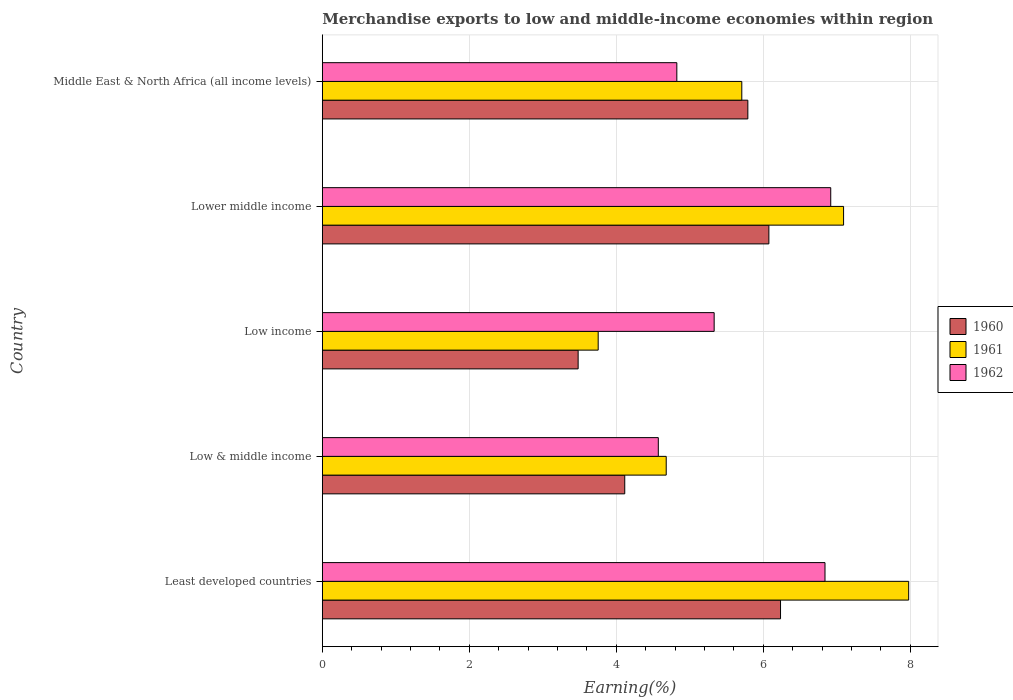How many groups of bars are there?
Provide a succinct answer. 5. Are the number of bars per tick equal to the number of legend labels?
Offer a terse response. Yes. Are the number of bars on each tick of the Y-axis equal?
Ensure brevity in your answer.  Yes. How many bars are there on the 3rd tick from the top?
Offer a very short reply. 3. What is the label of the 1st group of bars from the top?
Offer a very short reply. Middle East & North Africa (all income levels). In how many cases, is the number of bars for a given country not equal to the number of legend labels?
Offer a very short reply. 0. What is the percentage of amount earned from merchandise exports in 1961 in Least developed countries?
Provide a succinct answer. 7.98. Across all countries, what is the maximum percentage of amount earned from merchandise exports in 1961?
Your answer should be very brief. 7.98. Across all countries, what is the minimum percentage of amount earned from merchandise exports in 1962?
Provide a short and direct response. 4.57. In which country was the percentage of amount earned from merchandise exports in 1962 maximum?
Your answer should be compact. Lower middle income. In which country was the percentage of amount earned from merchandise exports in 1961 minimum?
Offer a terse response. Low income. What is the total percentage of amount earned from merchandise exports in 1961 in the graph?
Offer a terse response. 29.21. What is the difference between the percentage of amount earned from merchandise exports in 1961 in Low & middle income and that in Low income?
Provide a short and direct response. 0.93. What is the difference between the percentage of amount earned from merchandise exports in 1960 in Lower middle income and the percentage of amount earned from merchandise exports in 1961 in Low & middle income?
Your answer should be compact. 1.4. What is the average percentage of amount earned from merchandise exports in 1960 per country?
Your answer should be very brief. 5.14. What is the difference between the percentage of amount earned from merchandise exports in 1962 and percentage of amount earned from merchandise exports in 1961 in Least developed countries?
Provide a short and direct response. -1.14. What is the ratio of the percentage of amount earned from merchandise exports in 1961 in Low & middle income to that in Low income?
Your response must be concise. 1.25. Is the difference between the percentage of amount earned from merchandise exports in 1962 in Low & middle income and Lower middle income greater than the difference between the percentage of amount earned from merchandise exports in 1961 in Low & middle income and Lower middle income?
Offer a very short reply. Yes. What is the difference between the highest and the second highest percentage of amount earned from merchandise exports in 1961?
Your response must be concise. 0.89. What is the difference between the highest and the lowest percentage of amount earned from merchandise exports in 1962?
Your answer should be very brief. 2.35. In how many countries, is the percentage of amount earned from merchandise exports in 1962 greater than the average percentage of amount earned from merchandise exports in 1962 taken over all countries?
Ensure brevity in your answer.  2. How many bars are there?
Ensure brevity in your answer.  15. How many countries are there in the graph?
Your answer should be very brief. 5. Are the values on the major ticks of X-axis written in scientific E-notation?
Your answer should be very brief. No. Does the graph contain grids?
Make the answer very short. Yes. Where does the legend appear in the graph?
Make the answer very short. Center right. How are the legend labels stacked?
Make the answer very short. Vertical. What is the title of the graph?
Give a very brief answer. Merchandise exports to low and middle-income economies within region. What is the label or title of the X-axis?
Your response must be concise. Earning(%). What is the label or title of the Y-axis?
Provide a succinct answer. Country. What is the Earning(%) of 1960 in Least developed countries?
Offer a terse response. 6.23. What is the Earning(%) of 1961 in Least developed countries?
Offer a terse response. 7.98. What is the Earning(%) of 1962 in Least developed countries?
Offer a terse response. 6.84. What is the Earning(%) of 1960 in Low & middle income?
Your response must be concise. 4.11. What is the Earning(%) in 1961 in Low & middle income?
Provide a succinct answer. 4.68. What is the Earning(%) in 1962 in Low & middle income?
Provide a succinct answer. 4.57. What is the Earning(%) of 1960 in Low income?
Provide a succinct answer. 3.48. What is the Earning(%) of 1961 in Low income?
Your response must be concise. 3.75. What is the Earning(%) in 1962 in Low income?
Your response must be concise. 5.33. What is the Earning(%) of 1960 in Lower middle income?
Give a very brief answer. 6.07. What is the Earning(%) in 1961 in Lower middle income?
Your answer should be compact. 7.09. What is the Earning(%) of 1962 in Lower middle income?
Provide a succinct answer. 6.92. What is the Earning(%) in 1960 in Middle East & North Africa (all income levels)?
Your answer should be very brief. 5.79. What is the Earning(%) in 1961 in Middle East & North Africa (all income levels)?
Your response must be concise. 5.71. What is the Earning(%) of 1962 in Middle East & North Africa (all income levels)?
Keep it short and to the point. 4.82. Across all countries, what is the maximum Earning(%) of 1960?
Your answer should be very brief. 6.23. Across all countries, what is the maximum Earning(%) of 1961?
Ensure brevity in your answer.  7.98. Across all countries, what is the maximum Earning(%) in 1962?
Offer a terse response. 6.92. Across all countries, what is the minimum Earning(%) in 1960?
Your answer should be very brief. 3.48. Across all countries, what is the minimum Earning(%) of 1961?
Keep it short and to the point. 3.75. Across all countries, what is the minimum Earning(%) in 1962?
Keep it short and to the point. 4.57. What is the total Earning(%) in 1960 in the graph?
Provide a short and direct response. 25.69. What is the total Earning(%) of 1961 in the graph?
Offer a terse response. 29.21. What is the total Earning(%) of 1962 in the graph?
Provide a succinct answer. 28.48. What is the difference between the Earning(%) of 1960 in Least developed countries and that in Low & middle income?
Offer a very short reply. 2.12. What is the difference between the Earning(%) in 1961 in Least developed countries and that in Low & middle income?
Make the answer very short. 3.3. What is the difference between the Earning(%) in 1962 in Least developed countries and that in Low & middle income?
Ensure brevity in your answer.  2.27. What is the difference between the Earning(%) in 1960 in Least developed countries and that in Low income?
Your answer should be very brief. 2.75. What is the difference between the Earning(%) of 1961 in Least developed countries and that in Low income?
Offer a very short reply. 4.22. What is the difference between the Earning(%) in 1962 in Least developed countries and that in Low income?
Offer a terse response. 1.51. What is the difference between the Earning(%) of 1960 in Least developed countries and that in Lower middle income?
Offer a terse response. 0.16. What is the difference between the Earning(%) in 1961 in Least developed countries and that in Lower middle income?
Your answer should be compact. 0.89. What is the difference between the Earning(%) of 1962 in Least developed countries and that in Lower middle income?
Provide a short and direct response. -0.08. What is the difference between the Earning(%) in 1960 in Least developed countries and that in Middle East & North Africa (all income levels)?
Offer a very short reply. 0.44. What is the difference between the Earning(%) of 1961 in Least developed countries and that in Middle East & North Africa (all income levels)?
Keep it short and to the point. 2.27. What is the difference between the Earning(%) in 1962 in Least developed countries and that in Middle East & North Africa (all income levels)?
Offer a very short reply. 2.02. What is the difference between the Earning(%) of 1960 in Low & middle income and that in Low income?
Keep it short and to the point. 0.63. What is the difference between the Earning(%) of 1961 in Low & middle income and that in Low income?
Your answer should be very brief. 0.93. What is the difference between the Earning(%) in 1962 in Low & middle income and that in Low income?
Offer a terse response. -0.76. What is the difference between the Earning(%) in 1960 in Low & middle income and that in Lower middle income?
Keep it short and to the point. -1.96. What is the difference between the Earning(%) in 1961 in Low & middle income and that in Lower middle income?
Make the answer very short. -2.41. What is the difference between the Earning(%) in 1962 in Low & middle income and that in Lower middle income?
Keep it short and to the point. -2.35. What is the difference between the Earning(%) in 1960 in Low & middle income and that in Middle East & North Africa (all income levels)?
Your answer should be very brief. -1.67. What is the difference between the Earning(%) of 1961 in Low & middle income and that in Middle East & North Africa (all income levels)?
Make the answer very short. -1.03. What is the difference between the Earning(%) in 1962 in Low & middle income and that in Middle East & North Africa (all income levels)?
Your answer should be compact. -0.25. What is the difference between the Earning(%) in 1960 in Low income and that in Lower middle income?
Provide a succinct answer. -2.59. What is the difference between the Earning(%) of 1961 in Low income and that in Lower middle income?
Your answer should be compact. -3.34. What is the difference between the Earning(%) in 1962 in Low income and that in Lower middle income?
Keep it short and to the point. -1.59. What is the difference between the Earning(%) of 1960 in Low income and that in Middle East & North Africa (all income levels)?
Your answer should be very brief. -2.31. What is the difference between the Earning(%) of 1961 in Low income and that in Middle East & North Africa (all income levels)?
Keep it short and to the point. -1.95. What is the difference between the Earning(%) in 1962 in Low income and that in Middle East & North Africa (all income levels)?
Offer a very short reply. 0.51. What is the difference between the Earning(%) of 1960 in Lower middle income and that in Middle East & North Africa (all income levels)?
Make the answer very short. 0.29. What is the difference between the Earning(%) in 1961 in Lower middle income and that in Middle East & North Africa (all income levels)?
Provide a succinct answer. 1.38. What is the difference between the Earning(%) in 1962 in Lower middle income and that in Middle East & North Africa (all income levels)?
Make the answer very short. 2.09. What is the difference between the Earning(%) of 1960 in Least developed countries and the Earning(%) of 1961 in Low & middle income?
Offer a very short reply. 1.56. What is the difference between the Earning(%) of 1960 in Least developed countries and the Earning(%) of 1962 in Low & middle income?
Offer a very short reply. 1.66. What is the difference between the Earning(%) in 1961 in Least developed countries and the Earning(%) in 1962 in Low & middle income?
Provide a succinct answer. 3.41. What is the difference between the Earning(%) of 1960 in Least developed countries and the Earning(%) of 1961 in Low income?
Offer a very short reply. 2.48. What is the difference between the Earning(%) of 1960 in Least developed countries and the Earning(%) of 1962 in Low income?
Ensure brevity in your answer.  0.9. What is the difference between the Earning(%) of 1961 in Least developed countries and the Earning(%) of 1962 in Low income?
Your answer should be compact. 2.65. What is the difference between the Earning(%) of 1960 in Least developed countries and the Earning(%) of 1961 in Lower middle income?
Offer a terse response. -0.86. What is the difference between the Earning(%) in 1960 in Least developed countries and the Earning(%) in 1962 in Lower middle income?
Make the answer very short. -0.68. What is the difference between the Earning(%) in 1961 in Least developed countries and the Earning(%) in 1962 in Lower middle income?
Your answer should be very brief. 1.06. What is the difference between the Earning(%) in 1960 in Least developed countries and the Earning(%) in 1961 in Middle East & North Africa (all income levels)?
Provide a short and direct response. 0.53. What is the difference between the Earning(%) in 1960 in Least developed countries and the Earning(%) in 1962 in Middle East & North Africa (all income levels)?
Provide a succinct answer. 1.41. What is the difference between the Earning(%) in 1961 in Least developed countries and the Earning(%) in 1962 in Middle East & North Africa (all income levels)?
Offer a very short reply. 3.15. What is the difference between the Earning(%) of 1960 in Low & middle income and the Earning(%) of 1961 in Low income?
Ensure brevity in your answer.  0.36. What is the difference between the Earning(%) in 1960 in Low & middle income and the Earning(%) in 1962 in Low income?
Provide a short and direct response. -1.22. What is the difference between the Earning(%) in 1961 in Low & middle income and the Earning(%) in 1962 in Low income?
Provide a short and direct response. -0.65. What is the difference between the Earning(%) of 1960 in Low & middle income and the Earning(%) of 1961 in Lower middle income?
Offer a terse response. -2.98. What is the difference between the Earning(%) of 1960 in Low & middle income and the Earning(%) of 1962 in Lower middle income?
Offer a very short reply. -2.8. What is the difference between the Earning(%) in 1961 in Low & middle income and the Earning(%) in 1962 in Lower middle income?
Provide a succinct answer. -2.24. What is the difference between the Earning(%) of 1960 in Low & middle income and the Earning(%) of 1961 in Middle East & North Africa (all income levels)?
Give a very brief answer. -1.59. What is the difference between the Earning(%) of 1960 in Low & middle income and the Earning(%) of 1962 in Middle East & North Africa (all income levels)?
Offer a terse response. -0.71. What is the difference between the Earning(%) in 1961 in Low & middle income and the Earning(%) in 1962 in Middle East & North Africa (all income levels)?
Keep it short and to the point. -0.14. What is the difference between the Earning(%) of 1960 in Low income and the Earning(%) of 1961 in Lower middle income?
Keep it short and to the point. -3.61. What is the difference between the Earning(%) in 1960 in Low income and the Earning(%) in 1962 in Lower middle income?
Provide a succinct answer. -3.44. What is the difference between the Earning(%) in 1961 in Low income and the Earning(%) in 1962 in Lower middle income?
Ensure brevity in your answer.  -3.16. What is the difference between the Earning(%) of 1960 in Low income and the Earning(%) of 1961 in Middle East & North Africa (all income levels)?
Your answer should be very brief. -2.23. What is the difference between the Earning(%) of 1960 in Low income and the Earning(%) of 1962 in Middle East & North Africa (all income levels)?
Your response must be concise. -1.34. What is the difference between the Earning(%) in 1961 in Low income and the Earning(%) in 1962 in Middle East & North Africa (all income levels)?
Ensure brevity in your answer.  -1.07. What is the difference between the Earning(%) in 1960 in Lower middle income and the Earning(%) in 1961 in Middle East & North Africa (all income levels)?
Ensure brevity in your answer.  0.37. What is the difference between the Earning(%) of 1960 in Lower middle income and the Earning(%) of 1962 in Middle East & North Africa (all income levels)?
Offer a terse response. 1.25. What is the difference between the Earning(%) of 1961 in Lower middle income and the Earning(%) of 1962 in Middle East & North Africa (all income levels)?
Offer a terse response. 2.27. What is the average Earning(%) of 1960 per country?
Keep it short and to the point. 5.14. What is the average Earning(%) in 1961 per country?
Ensure brevity in your answer.  5.84. What is the average Earning(%) of 1962 per country?
Ensure brevity in your answer.  5.7. What is the difference between the Earning(%) in 1960 and Earning(%) in 1961 in Least developed countries?
Offer a very short reply. -1.74. What is the difference between the Earning(%) of 1960 and Earning(%) of 1962 in Least developed countries?
Give a very brief answer. -0.6. What is the difference between the Earning(%) of 1961 and Earning(%) of 1962 in Least developed countries?
Offer a terse response. 1.14. What is the difference between the Earning(%) in 1960 and Earning(%) in 1961 in Low & middle income?
Your answer should be very brief. -0.56. What is the difference between the Earning(%) of 1960 and Earning(%) of 1962 in Low & middle income?
Provide a short and direct response. -0.46. What is the difference between the Earning(%) in 1961 and Earning(%) in 1962 in Low & middle income?
Keep it short and to the point. 0.11. What is the difference between the Earning(%) in 1960 and Earning(%) in 1961 in Low income?
Your answer should be very brief. -0.27. What is the difference between the Earning(%) in 1960 and Earning(%) in 1962 in Low income?
Give a very brief answer. -1.85. What is the difference between the Earning(%) in 1961 and Earning(%) in 1962 in Low income?
Your response must be concise. -1.58. What is the difference between the Earning(%) in 1960 and Earning(%) in 1961 in Lower middle income?
Offer a very short reply. -1.02. What is the difference between the Earning(%) of 1960 and Earning(%) of 1962 in Lower middle income?
Your answer should be compact. -0.84. What is the difference between the Earning(%) in 1961 and Earning(%) in 1962 in Lower middle income?
Give a very brief answer. 0.17. What is the difference between the Earning(%) of 1960 and Earning(%) of 1961 in Middle East & North Africa (all income levels)?
Offer a very short reply. 0.08. What is the difference between the Earning(%) in 1960 and Earning(%) in 1962 in Middle East & North Africa (all income levels)?
Ensure brevity in your answer.  0.97. What is the difference between the Earning(%) of 1961 and Earning(%) of 1962 in Middle East & North Africa (all income levels)?
Offer a very short reply. 0.88. What is the ratio of the Earning(%) in 1960 in Least developed countries to that in Low & middle income?
Your answer should be very brief. 1.52. What is the ratio of the Earning(%) of 1961 in Least developed countries to that in Low & middle income?
Offer a very short reply. 1.71. What is the ratio of the Earning(%) in 1962 in Least developed countries to that in Low & middle income?
Make the answer very short. 1.5. What is the ratio of the Earning(%) of 1960 in Least developed countries to that in Low income?
Give a very brief answer. 1.79. What is the ratio of the Earning(%) of 1961 in Least developed countries to that in Low income?
Offer a very short reply. 2.13. What is the ratio of the Earning(%) in 1962 in Least developed countries to that in Low income?
Your answer should be compact. 1.28. What is the ratio of the Earning(%) of 1960 in Least developed countries to that in Lower middle income?
Provide a short and direct response. 1.03. What is the ratio of the Earning(%) in 1961 in Least developed countries to that in Lower middle income?
Keep it short and to the point. 1.12. What is the ratio of the Earning(%) in 1962 in Least developed countries to that in Lower middle income?
Give a very brief answer. 0.99. What is the ratio of the Earning(%) in 1960 in Least developed countries to that in Middle East & North Africa (all income levels)?
Offer a very short reply. 1.08. What is the ratio of the Earning(%) in 1961 in Least developed countries to that in Middle East & North Africa (all income levels)?
Keep it short and to the point. 1.4. What is the ratio of the Earning(%) in 1962 in Least developed countries to that in Middle East & North Africa (all income levels)?
Offer a terse response. 1.42. What is the ratio of the Earning(%) of 1960 in Low & middle income to that in Low income?
Your response must be concise. 1.18. What is the ratio of the Earning(%) in 1961 in Low & middle income to that in Low income?
Offer a very short reply. 1.25. What is the ratio of the Earning(%) in 1962 in Low & middle income to that in Low income?
Give a very brief answer. 0.86. What is the ratio of the Earning(%) in 1960 in Low & middle income to that in Lower middle income?
Your answer should be compact. 0.68. What is the ratio of the Earning(%) in 1961 in Low & middle income to that in Lower middle income?
Your answer should be compact. 0.66. What is the ratio of the Earning(%) in 1962 in Low & middle income to that in Lower middle income?
Offer a very short reply. 0.66. What is the ratio of the Earning(%) in 1960 in Low & middle income to that in Middle East & North Africa (all income levels)?
Offer a very short reply. 0.71. What is the ratio of the Earning(%) of 1961 in Low & middle income to that in Middle East & North Africa (all income levels)?
Provide a short and direct response. 0.82. What is the ratio of the Earning(%) in 1962 in Low & middle income to that in Middle East & North Africa (all income levels)?
Your answer should be compact. 0.95. What is the ratio of the Earning(%) of 1960 in Low income to that in Lower middle income?
Give a very brief answer. 0.57. What is the ratio of the Earning(%) of 1961 in Low income to that in Lower middle income?
Offer a terse response. 0.53. What is the ratio of the Earning(%) in 1962 in Low income to that in Lower middle income?
Your answer should be very brief. 0.77. What is the ratio of the Earning(%) in 1960 in Low income to that in Middle East & North Africa (all income levels)?
Offer a terse response. 0.6. What is the ratio of the Earning(%) of 1961 in Low income to that in Middle East & North Africa (all income levels)?
Your response must be concise. 0.66. What is the ratio of the Earning(%) of 1962 in Low income to that in Middle East & North Africa (all income levels)?
Make the answer very short. 1.11. What is the ratio of the Earning(%) in 1960 in Lower middle income to that in Middle East & North Africa (all income levels)?
Your answer should be very brief. 1.05. What is the ratio of the Earning(%) of 1961 in Lower middle income to that in Middle East & North Africa (all income levels)?
Provide a succinct answer. 1.24. What is the ratio of the Earning(%) of 1962 in Lower middle income to that in Middle East & North Africa (all income levels)?
Provide a short and direct response. 1.43. What is the difference between the highest and the second highest Earning(%) of 1960?
Keep it short and to the point. 0.16. What is the difference between the highest and the second highest Earning(%) in 1961?
Offer a very short reply. 0.89. What is the difference between the highest and the second highest Earning(%) in 1962?
Your answer should be very brief. 0.08. What is the difference between the highest and the lowest Earning(%) of 1960?
Ensure brevity in your answer.  2.75. What is the difference between the highest and the lowest Earning(%) of 1961?
Your answer should be compact. 4.22. What is the difference between the highest and the lowest Earning(%) in 1962?
Make the answer very short. 2.35. 